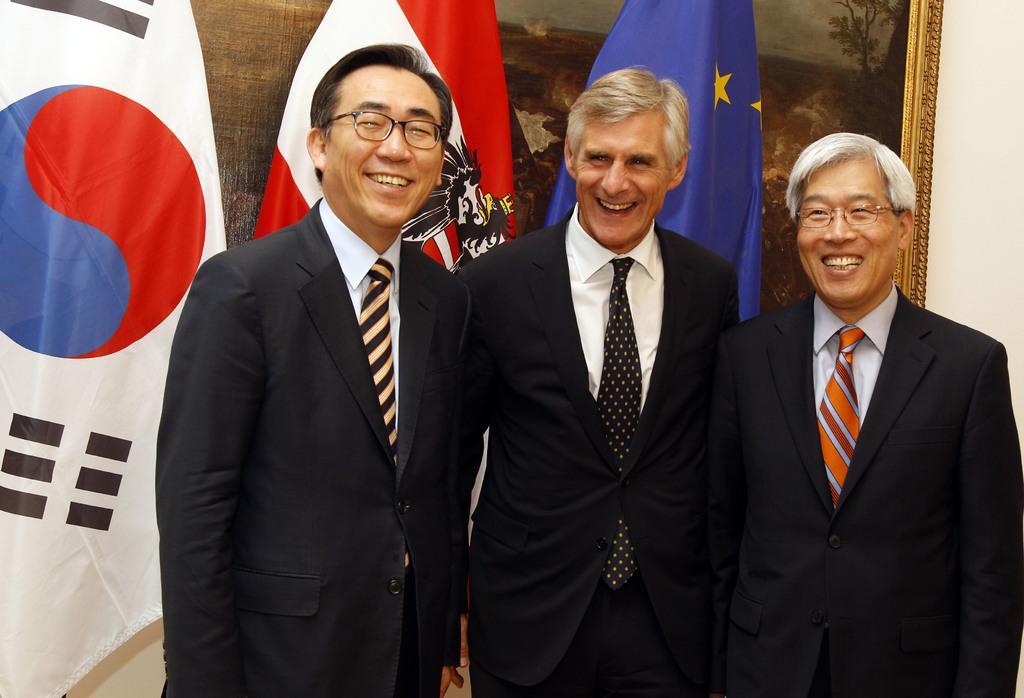Please provide a concise description of this image. There are three persons standing and smiling. Two are wearing specs. In the back there are flags. Also there is a frame with painting on the wall. 